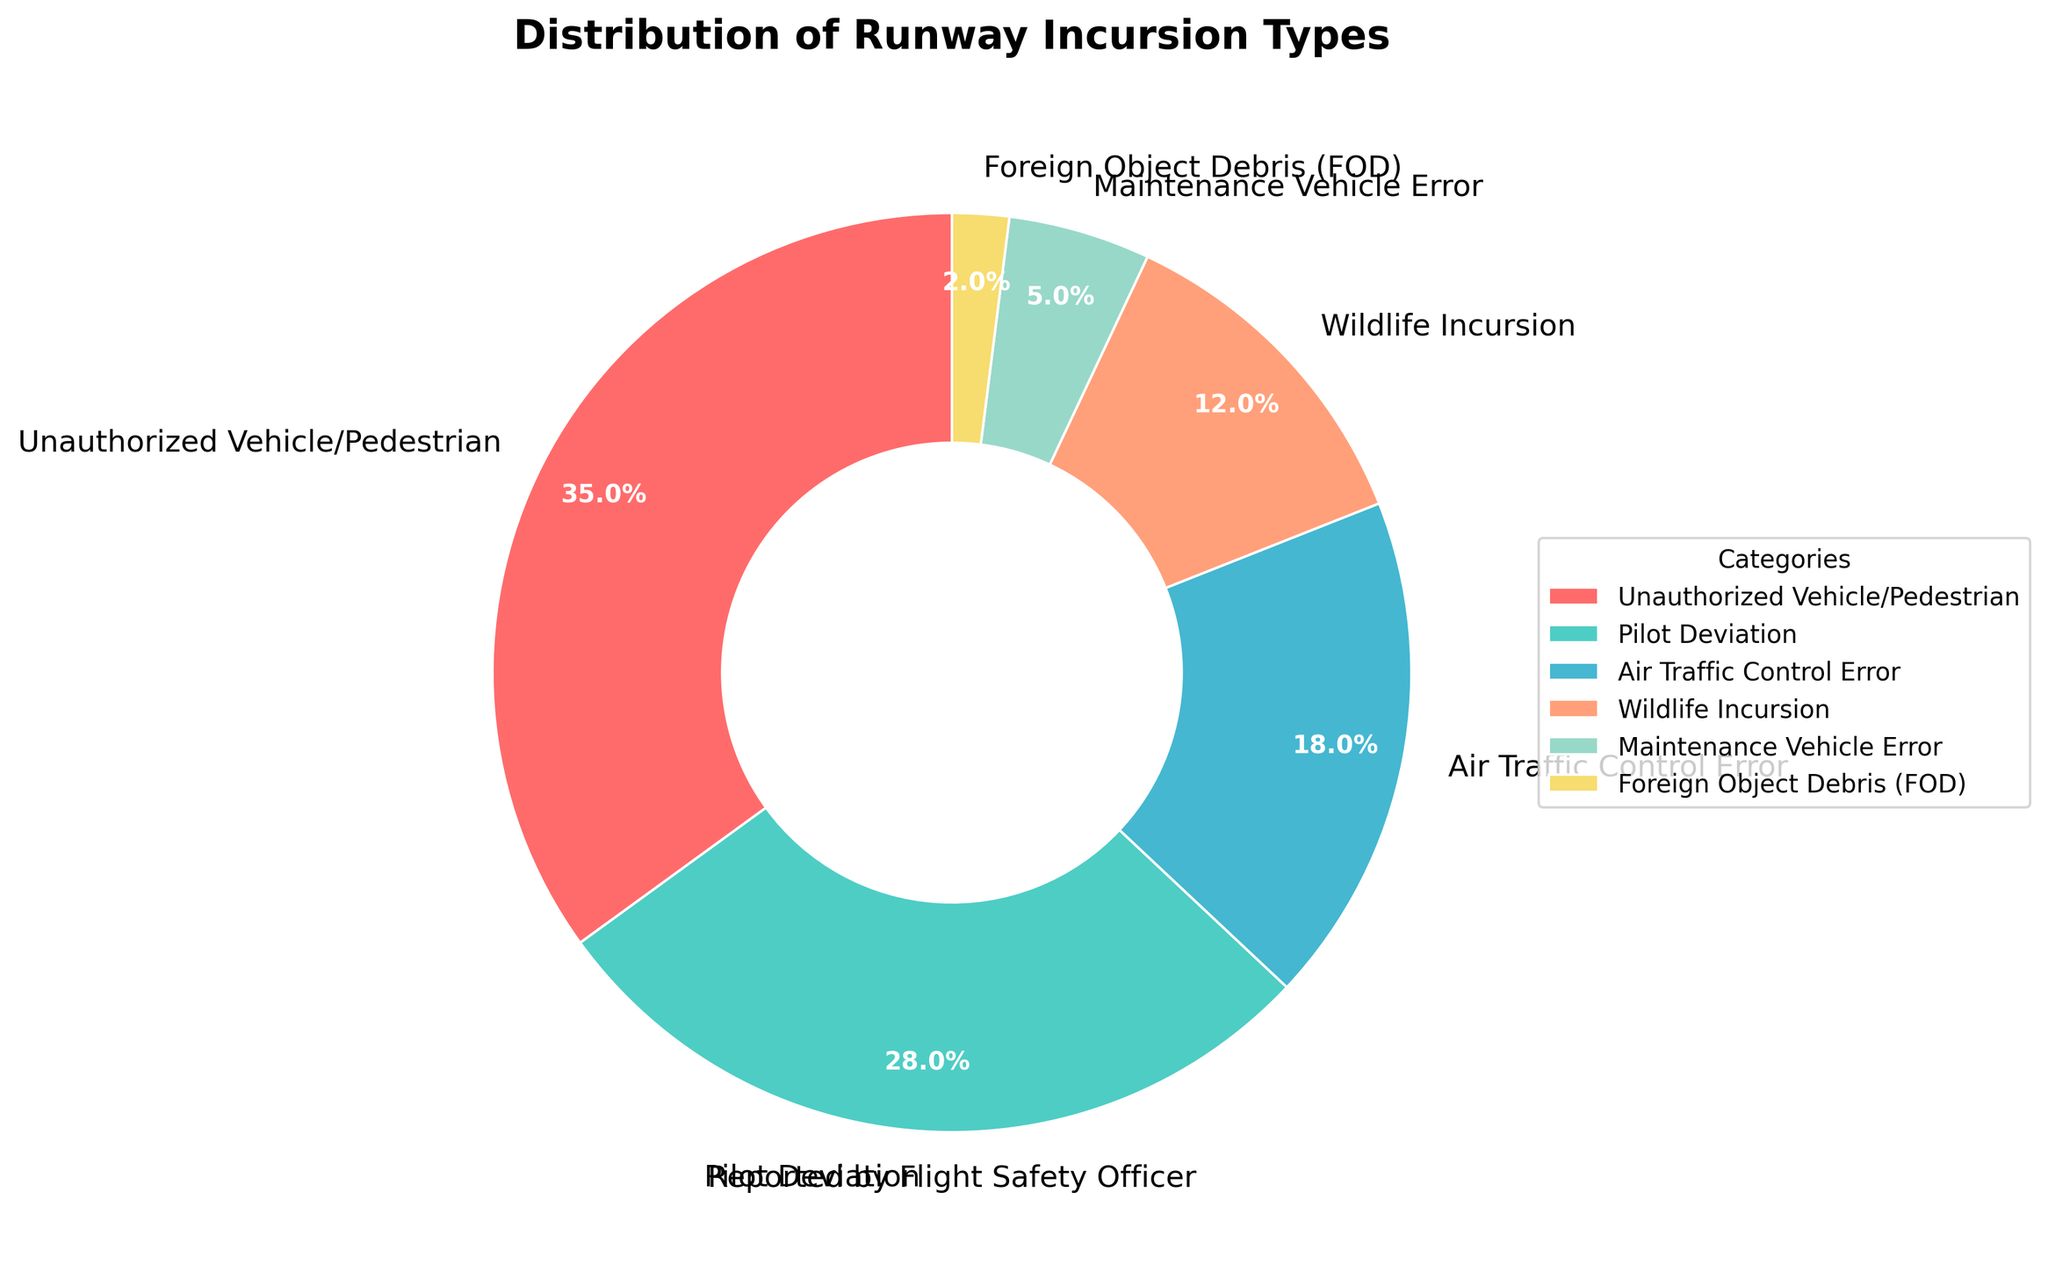Which type of runway incursion has the highest percentage? Look at the pie chart and identify which section takes up the largest portion. The "Unauthorized Vehicle/Pedestrian" category occupies the largest area with 35%.
Answer: Unauthorized Vehicle/Pedestrian What is the combined percentage of Pilot Deviation and Air Traffic Control Error? Add the percentage values for the "Pilot Deviation" (28%) and "Air Traffic Control Error" (18%) categories. 28% + 18% = 46%.
Answer: 46% Which category has a smaller percentage, Wildlife Incursion or Maintenance Vehicle Error? Compare the percentages of the "Wildlife Incursion" (12%) and "Maintenance Vehicle Error" (5%) categories. Wildlife Incursion is larger. Maintenance Vehicle Error has a smaller percentage.
Answer: Maintenance Vehicle Error How much more common are Unauthorized Vehicle/Pedestrian incursions than Foreign Object Debris (FOD) incursions? Subtract the percentage of "Foreign Object Debris (FOD)" (2%) from "Unauthorized Vehicle/Pedestrian" (35%). 35% - 2% = 33%.
Answer: 33% Which category occupies a portion of the pie chart that is roughly half the size of the Wildlife Incursion category? Compare the percentages and look for a category with around half of 12%. "Maintenance Vehicle Error" is 5%, approximately half of 12%.
Answer: Maintenance Vehicle Error Rank the incursion types from most common to least common. List the categories in descending order based on their percentages: Unauthorized Vehicle/Pedestrian (35%), Pilot Deviation (28%), Air Traffic Control Error (18%), Wildlife Incursion (12%), Maintenance Vehicle Error (5%), Foreign Object Debris (FOD) (2%).
Answer: Unauthorized Vehicle/Pedestrian, Pilot Deviation, Air Traffic Control Error, Wildlife Incursion, Maintenance Vehicle Error, Foreign Object Debris (FOD) Is the sum of the percentages of Unauthorized Vehicle/Pedestrian and Air Traffic Control Error more than 50%? Add the percentages of "Unauthorized Vehicle/Pedestrian" (35%) and "Air Traffic Control Error" (18%) and compare it to 50%. 35% + 18% = 53%, which is more than 50%.
Answer: Yes What is the difference between the percentage of Pilot Deviation and the smallest percentage in the chart? Subtract the smallest percentage "Foreign Object Debris (FOD)" (2%) from "Pilot Deviation" (28%). 28% - 2% = 26%.
Answer: 26% What fraction of the pie chart is taken up by Wildlife Incursion, expressed in simplest form? Convert the percentage to a fraction and simplify. Wildlife Incursion is 12%, which translates to 12/100 and simplifies to 3/25.
Answer: 3/25 